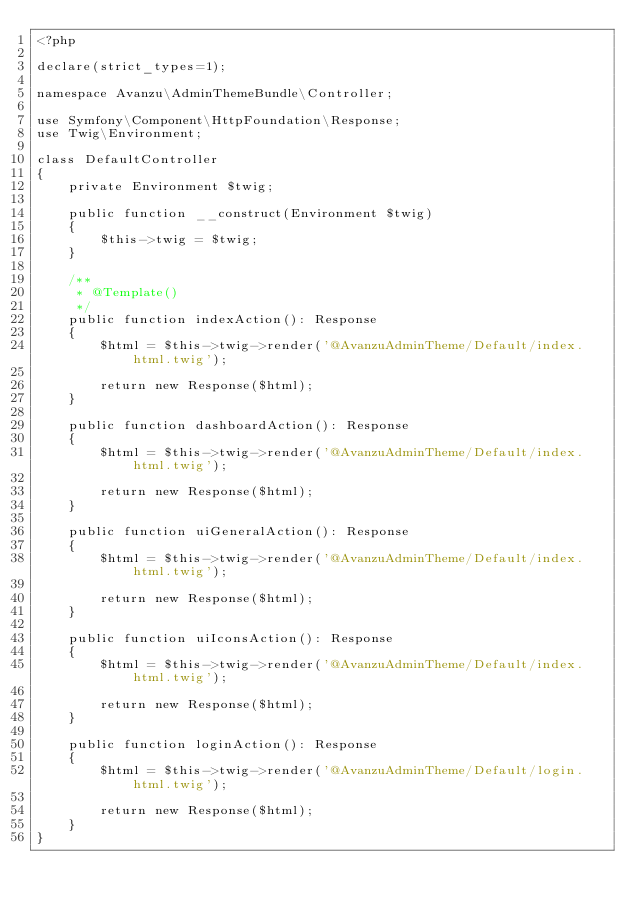Convert code to text. <code><loc_0><loc_0><loc_500><loc_500><_PHP_><?php

declare(strict_types=1);

namespace Avanzu\AdminThemeBundle\Controller;

use Symfony\Component\HttpFoundation\Response;
use Twig\Environment;

class DefaultController
{
    private Environment $twig;

    public function __construct(Environment $twig)
    {
        $this->twig = $twig;
    }

    /**
     * @Template()
     */
    public function indexAction(): Response
    {
        $html = $this->twig->render('@AvanzuAdminTheme/Default/index.html.twig');

        return new Response($html);
    }

    public function dashboardAction(): Response
    {
        $html = $this->twig->render('@AvanzuAdminTheme/Default/index.html.twig');

        return new Response($html);
    }

    public function uiGeneralAction(): Response
    {
        $html = $this->twig->render('@AvanzuAdminTheme/Default/index.html.twig');

        return new Response($html);
    }

    public function uiIconsAction(): Response
    {
        $html = $this->twig->render('@AvanzuAdminTheme/Default/index.html.twig');

        return new Response($html);
    }

    public function loginAction(): Response
    {
        $html = $this->twig->render('@AvanzuAdminTheme/Default/login.html.twig');

        return new Response($html);
    }
}
</code> 